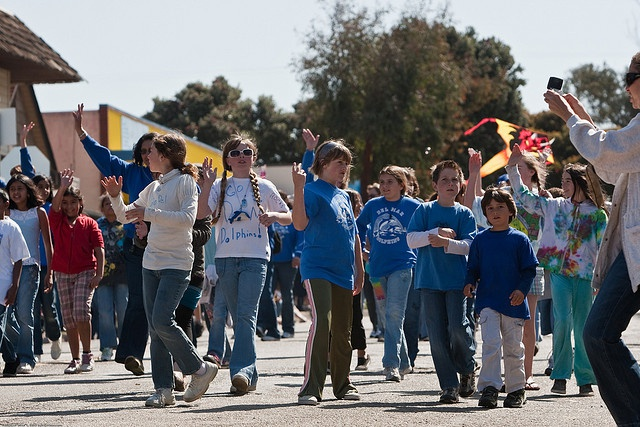Describe the objects in this image and their specific colors. I can see people in lightgray, black, gray, and navy tones, people in lightgray, black, and gray tones, people in lightgray, black, and gray tones, people in lightgray, black, navy, brown, and maroon tones, and people in lightgray, gray, and darkblue tones in this image. 